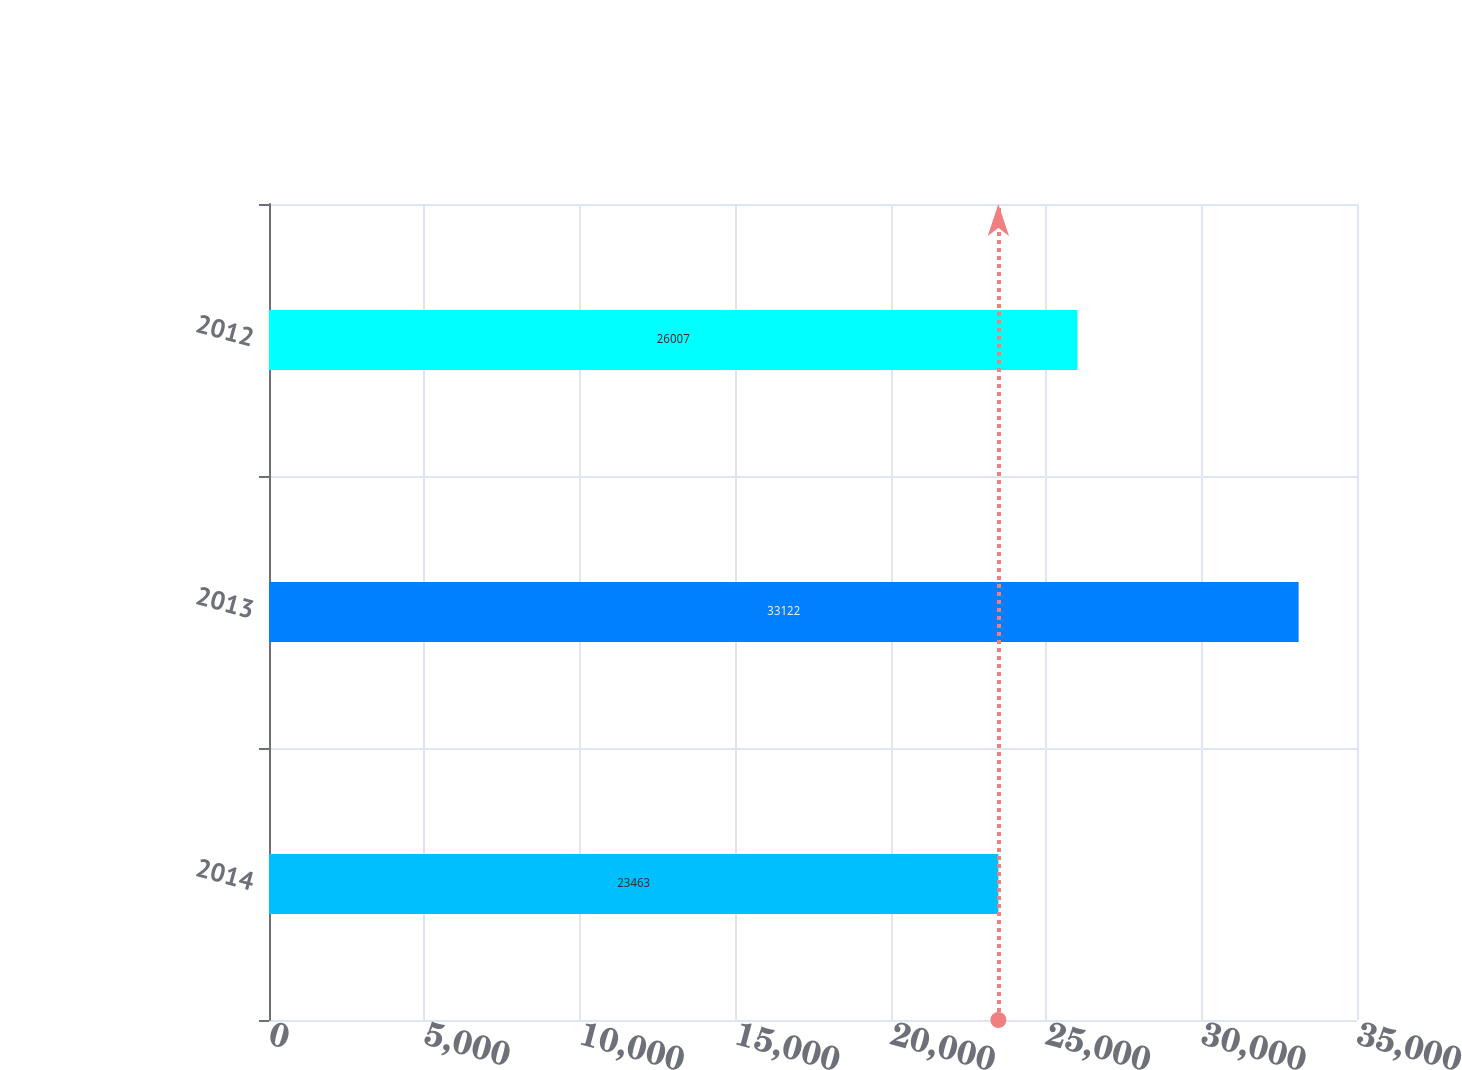Convert chart. <chart><loc_0><loc_0><loc_500><loc_500><bar_chart><fcel>2014<fcel>2013<fcel>2012<nl><fcel>23463<fcel>33122<fcel>26007<nl></chart> 